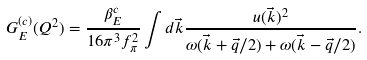<formula> <loc_0><loc_0><loc_500><loc_500>G _ { E } ^ { ( c ) } ( Q ^ { 2 } ) = \frac { \beta _ { E } ^ { c } } { 1 6 \pi ^ { 3 } f _ { \pi } ^ { 2 } } \int d \vec { k } \frac { u ( \vec { k } ) ^ { 2 } } { \omega ( \vec { k } + \vec { q } / 2 ) + \omega ( \vec { k } - \vec { q } / 2 ) } .</formula> 